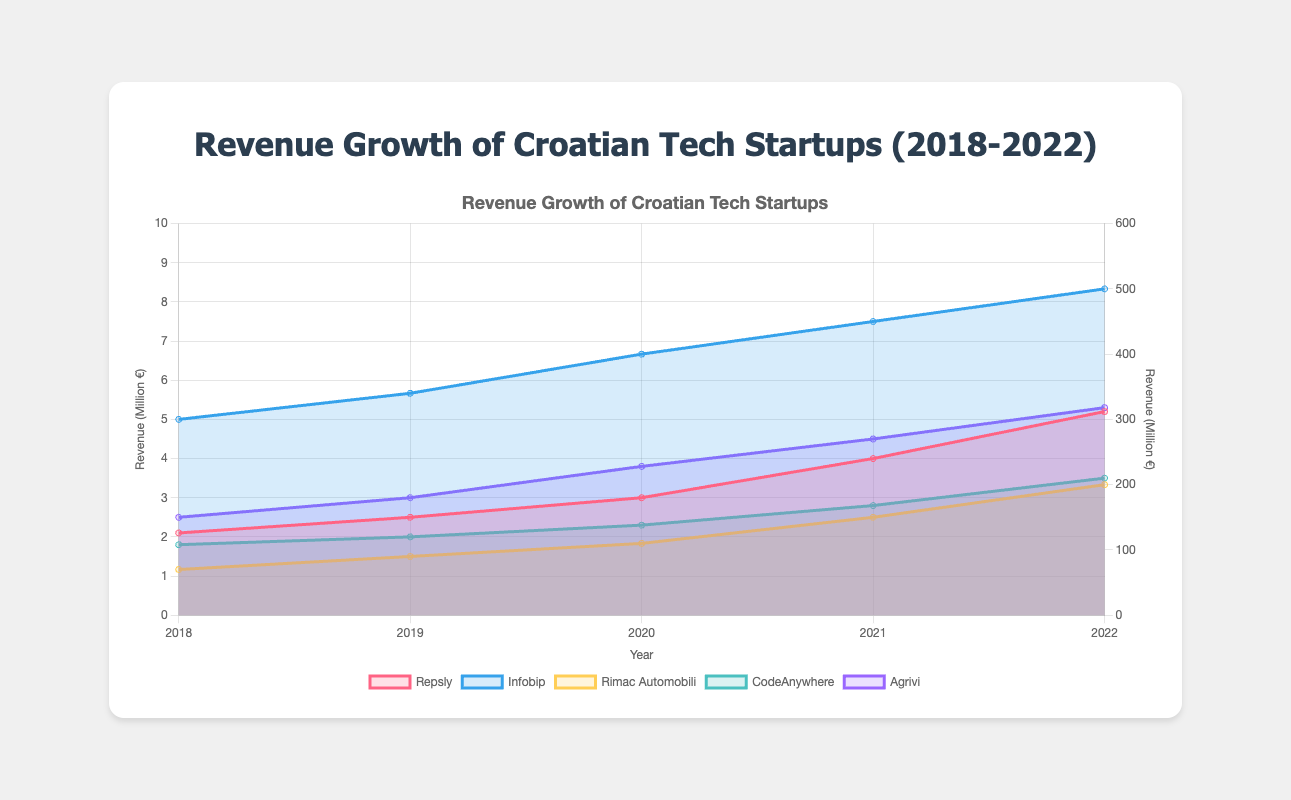What's the title of the figure? The title is usually displayed at the top of the figure. For this chart, it's centered at the top in bold text.
Answer: Revenue Growth of Croatian Tech Startups (2018-2022) What do the x-axis and y-axis represent? The x-axis represents the years from 2018 to 2022, while the y-axis on the left represents revenue in millions of euros for Repsly, CodeAnywhere, and Agrivi. The y-axis on the right represents revenue in millions of euros for Infobip and Rimac Automobili. The axis titles clarify this information.
Answer: The x-axis represents years, and the left y-axis represents revenue for Repsly, CodeAnywhere, and Agrivi. The right y-axis represents revenue for Infobip and Rimac Automobili Which startup showed the highest revenue in 2022? By looking at the data points and respective lines for each startup for the year 2022, Infobip has the highest value among all displayed startups.
Answer: Infobip How did the revenue of Agrivi change from 2018 to 2022? Observing the data points for Agrivi from 2018 to 2022, the revenue increased from 2.5 million euros in 2018 to 5.3 million euros in 2022.
Answer: It increased from 2.5 to 5.3 million euros Which startups had a revenue of more than 100 million euros by 2022? From the chart, only Infobip and Rimac Automobili's revenue exceed 100 million euros by 2022.
Answer: Infobip and Rimac Automobili What is the average revenue of CodeAnywhere over the five-year period? The revenues for CodeAnywhere from 2018 to 2022 are 1.8, 2, 2.3, 2.8, and 3.5. Summing these values and dividing by 5 gives the average: (1.8 + 2 + 2.3 + 2.8 + 3.5) / 5 = 12.4 / 5 = 2.48.
Answer: 2.48 million euros Which startup showed the largest absolute growth in revenue from 2018 to 2022? Comparing the changes, Infobip grew from 300 to 500 million euros (a 200 million euro increase), while Rimac Automobili increased by 130 (200-70). Infobip’s growth was the largest.
Answer: Infobip What is the combined revenue of Repsly and Agrivi in 2020? In 2020, Repsly had 3 million euros and Agrivi had 3.8 million euros. Adding these gives 3 + 3.8 = 6.8 million euros.
Answer: 6.8 million euros Which startups experienced revenue growth every year from 2018 to 2022? Observing the line increases every year without any decline, Repsly, Infobip, Rimac Automobili, CodeAnywhere, and Agrivi all experienced continuous growth.
Answer: All of them Which startup had the least revenue in 2019? Comparing the data points for 2019, CodeAnywhere had the smallest revenue at 2 million euros.
Answer: CodeAnywhere 